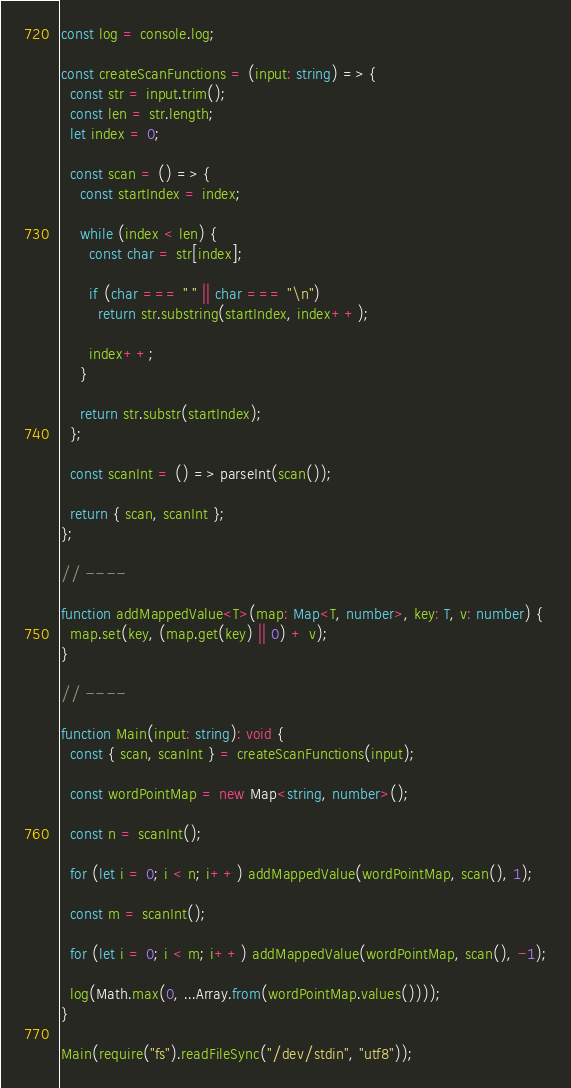<code> <loc_0><loc_0><loc_500><loc_500><_TypeScript_>const log = console.log;

const createScanFunctions = (input: string) => {
  const str = input.trim();
  const len = str.length;
  let index = 0;

  const scan = () => {
    const startIndex = index;

    while (index < len) {
      const char = str[index];

      if (char === " " || char === "\n")
        return str.substring(startIndex, index++);

      index++;
    }

    return str.substr(startIndex);
  };

  const scanInt = () => parseInt(scan());

  return { scan, scanInt };
};

// ----

function addMappedValue<T>(map: Map<T, number>, key: T, v: number) {
  map.set(key, (map.get(key) || 0) + v);
}

// ----

function Main(input: string): void {
  const { scan, scanInt } = createScanFunctions(input);

  const wordPointMap = new Map<string, number>();

  const n = scanInt();

  for (let i = 0; i < n; i++) addMappedValue(wordPointMap, scan(), 1);

  const m = scanInt();

  for (let i = 0; i < m; i++) addMappedValue(wordPointMap, scan(), -1);

  log(Math.max(0, ...Array.from(wordPointMap.values())));
}

Main(require("fs").readFileSync("/dev/stdin", "utf8"));</code> 